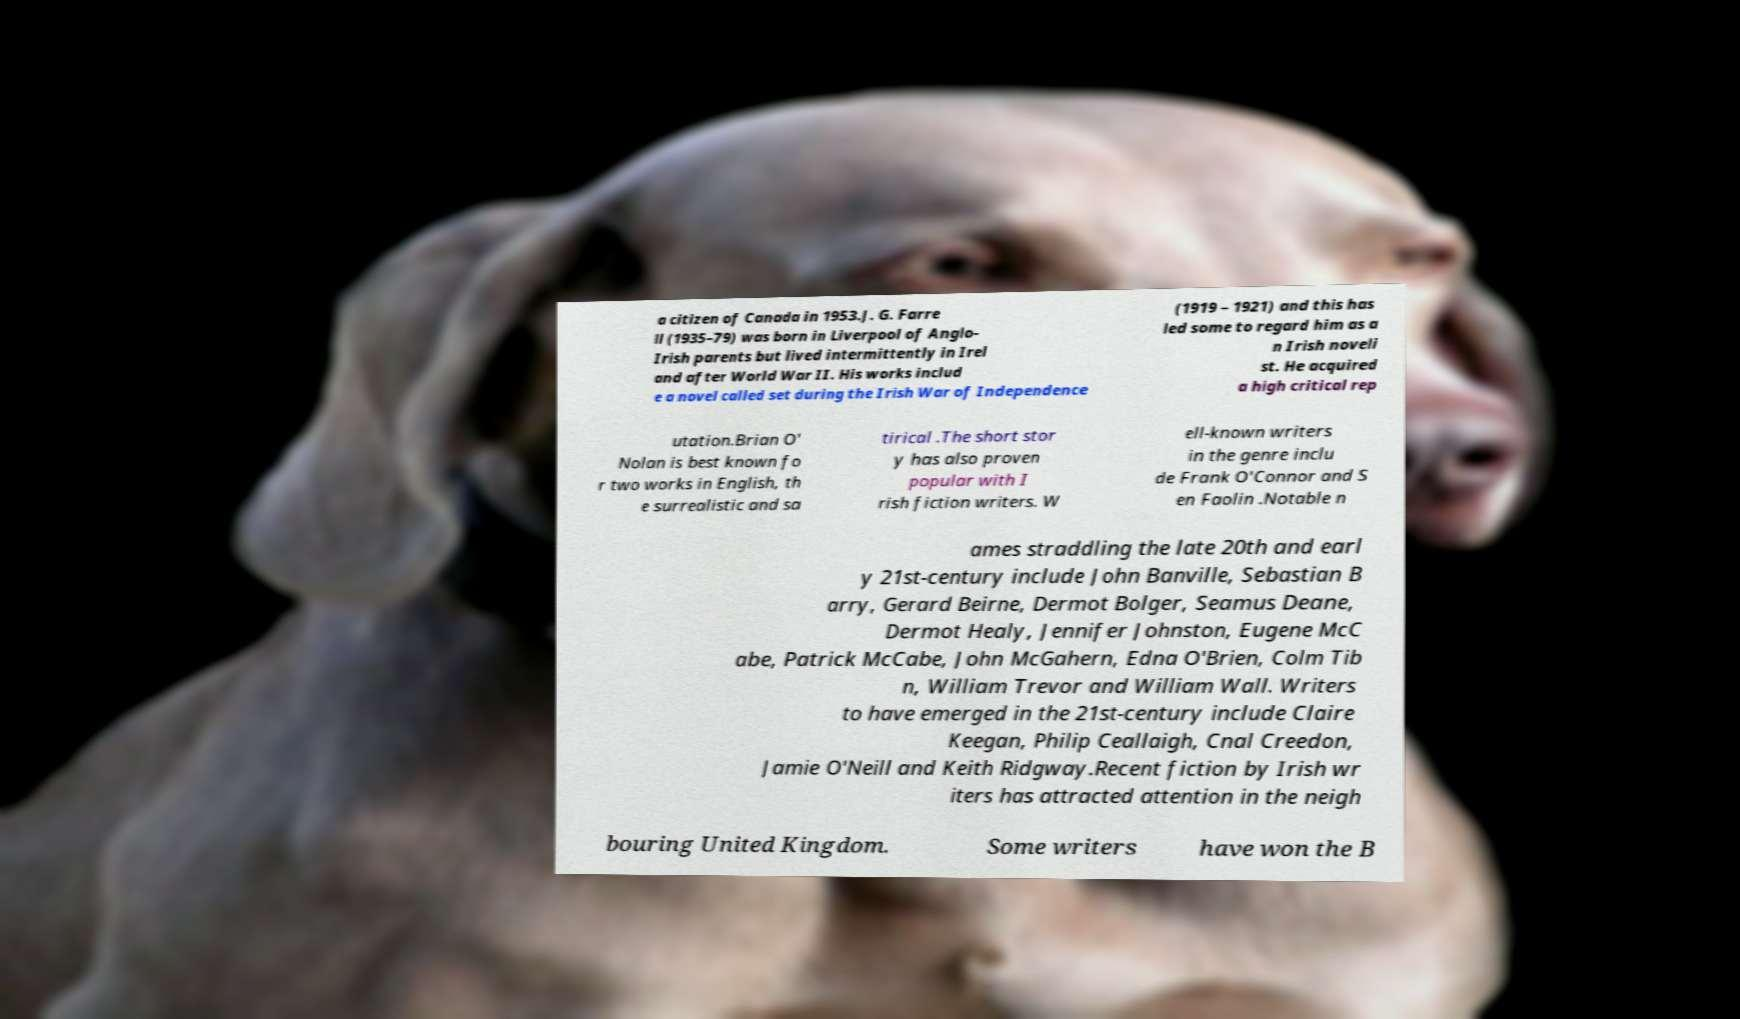Can you read and provide the text displayed in the image?This photo seems to have some interesting text. Can you extract and type it out for me? a citizen of Canada in 1953.J. G. Farre ll (1935–79) was born in Liverpool of Anglo- Irish parents but lived intermittently in Irel and after World War II. His works includ e a novel called set during the Irish War of Independence (1919 – 1921) and this has led some to regard him as a n Irish noveli st. He acquired a high critical rep utation.Brian O' Nolan is best known fo r two works in English, th e surrealistic and sa tirical .The short stor y has also proven popular with I rish fiction writers. W ell-known writers in the genre inclu de Frank O'Connor and S en Faolin .Notable n ames straddling the late 20th and earl y 21st-century include John Banville, Sebastian B arry, Gerard Beirne, Dermot Bolger, Seamus Deane, Dermot Healy, Jennifer Johnston, Eugene McC abe, Patrick McCabe, John McGahern, Edna O'Brien, Colm Tib n, William Trevor and William Wall. Writers to have emerged in the 21st-century include Claire Keegan, Philip Ceallaigh, Cnal Creedon, Jamie O'Neill and Keith Ridgway.Recent fiction by Irish wr iters has attracted attention in the neigh bouring United Kingdom. Some writers have won the B 